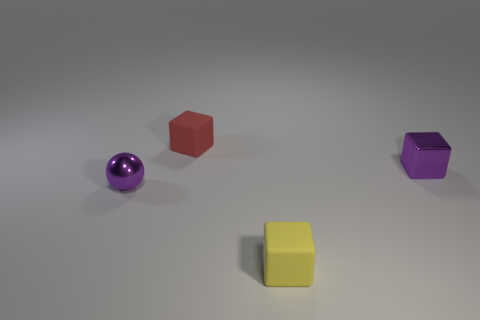The other tiny matte thing that is the same shape as the yellow thing is what color? The item that shares the same cubic shape as the yellow object is purple in color, displaying a matte finish similar to that of the yellow cube, which adds a subtle diversity to the palette of objects presented in the image. 